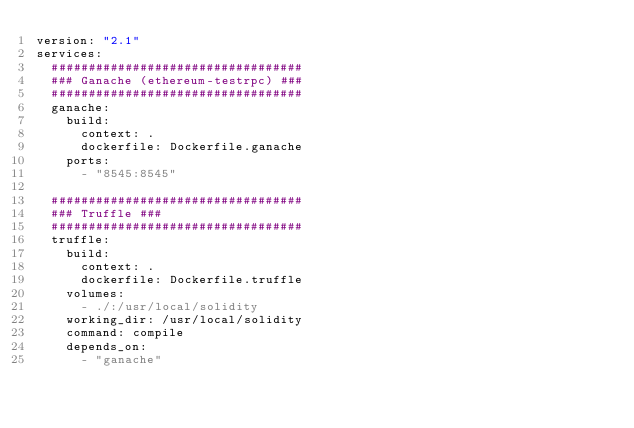<code> <loc_0><loc_0><loc_500><loc_500><_YAML_>version: "2.1"
services:
  ##################################
  ### Ganache (ethereum-testrpc) ###
  ##################################
  ganache:
    build:
      context: .
      dockerfile: Dockerfile.ganache
    ports:
      - "8545:8545"

  ##################################
  ### Truffle ###
  ##################################
  truffle:
    build:
      context: .
      dockerfile: Dockerfile.truffle
    volumes:
      - ./:/usr/local/solidity
    working_dir: /usr/local/solidity
    command: compile
    depends_on:
      - "ganache"
</code> 